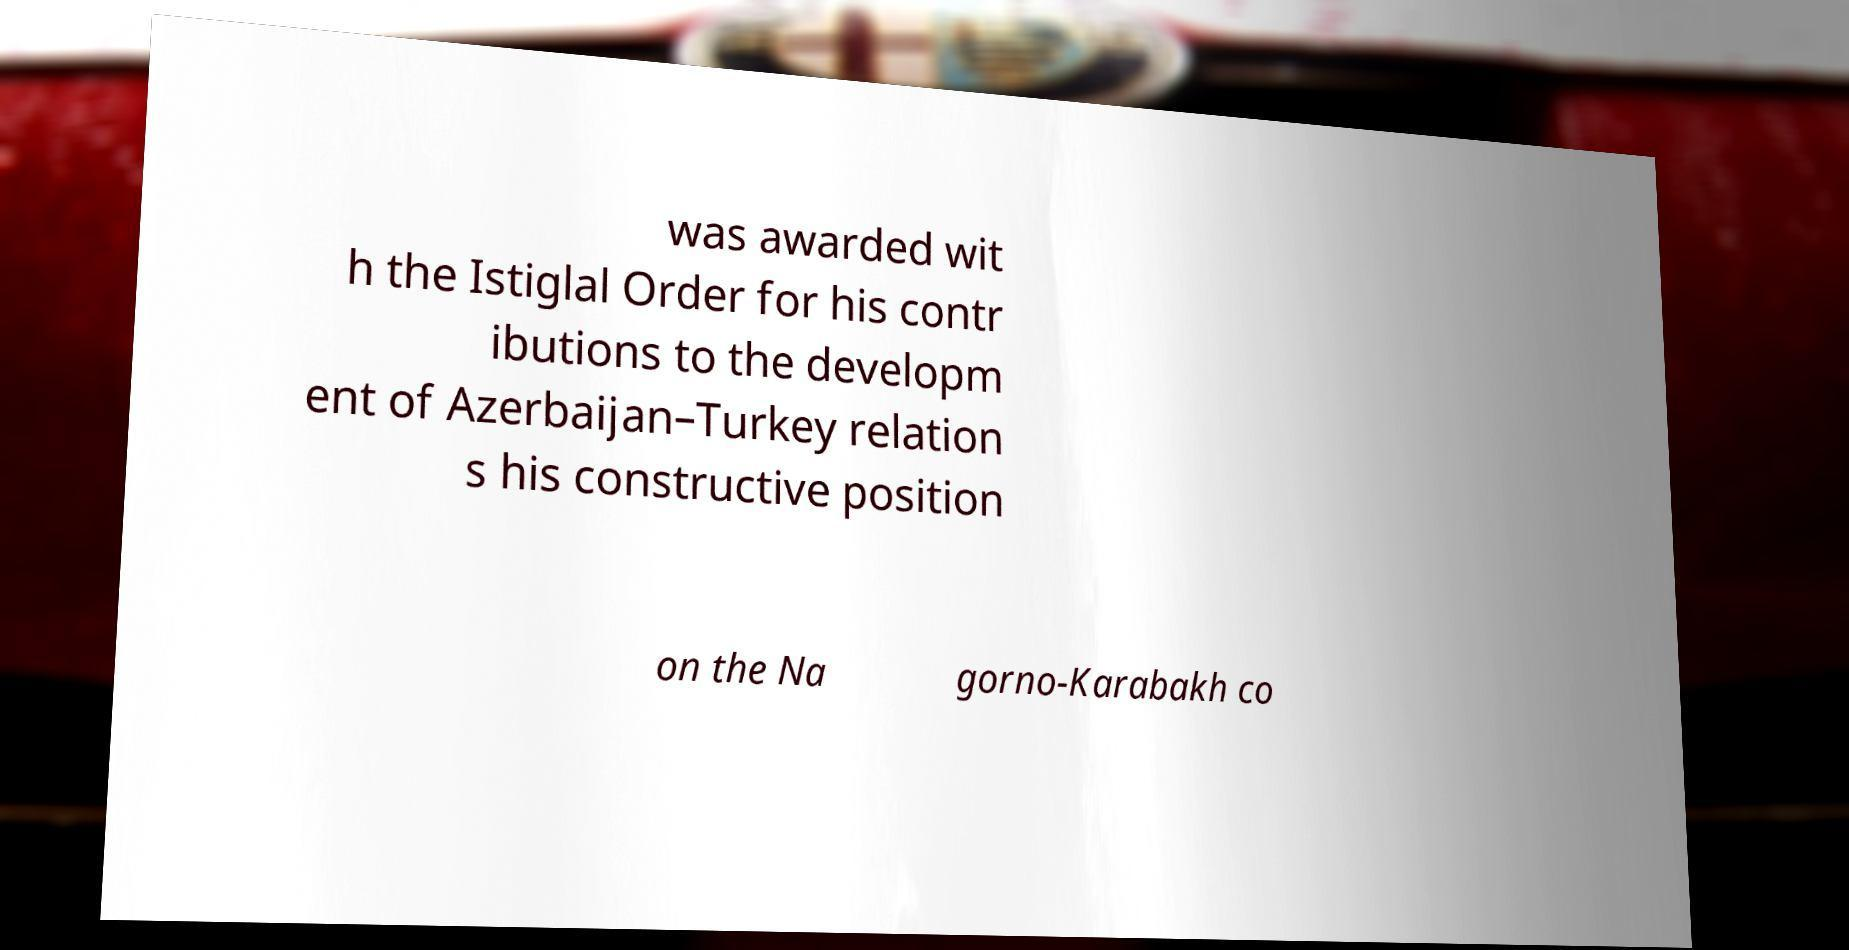Could you extract and type out the text from this image? was awarded wit h the Istiglal Order for his contr ibutions to the developm ent of Azerbaijan–Turkey relation s his constructive position on the Na gorno-Karabakh co 